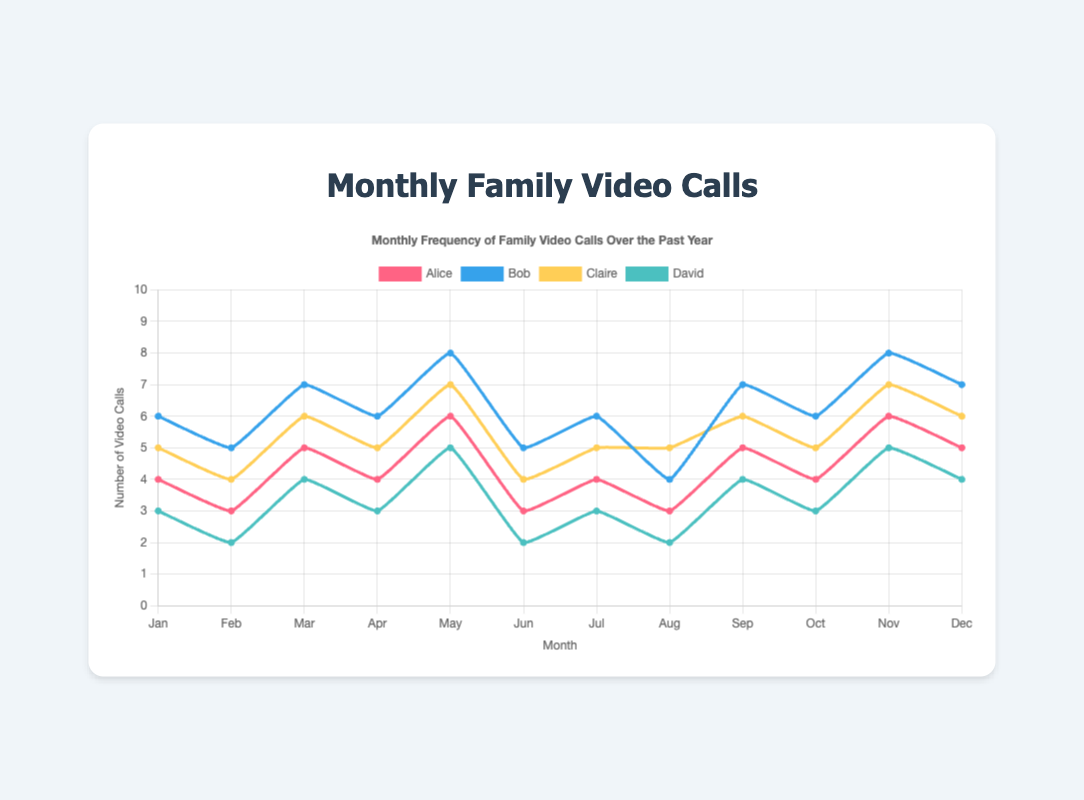What's the total number of video calls by Alice in the second half of the year? To find the total, add Alice's monthly frequency for July through December: 4 + 3 + 5 + 4 + 6 + 5 = 27
Answer: 27 Whose video call frequency was the highest in March? In March, compare the frequencies: Alice (5), Bob (7), Claire (6), David (4). Bob had the highest frequency.
Answer: Bob In which month did David have the lowest frequency of video calls? Check David's frequency across all months. David had the lowest frequency (2) in February, June, and August.
Answer: February, June, and August By how many calls did Bob's video call frequency exceed Alice's in November? In November, Bob had 8 calls and Alice had 6. The difference is 8 - 6 = 2 calls.
Answer: 2 Who had a more consistent video call frequency throughout the year, Claire or David? Calculate the range (max - min) for both: Claire's range is 7 - 4 = 3, David's range is 5 - 2 = 3. Both had the same range, comparing visually Claire seems more consistent with fewer fluctuations within her range.
Answer: Claire What's the overall trend in the frequency of Bob's video calls from January to December? Visually inspect Bob's trend: it peaks generally every two months and remains relatively high, with minor fluctuations. It seems stable with slight increases in May and November.
Answer: Stable with slight peaks If we average the number of calls for each person, who had the highest average frequency and what was it? Sum and divide each person's total across 12 months: 
- Alice: (4+3+5+4+6+3+4+3+5+4+6+5)/12 = 4.42 
- Bob: (6+5+7+6+8+5+6+4+7+6+8+7)/12 = 6.17 
- Claire: (5+4+6+5+7+4+5+5+6+5+7+6)/12 = 5.33 
- David: (3+2+4+3+5+2+3+2+4+3+5+4)/12 = 3.42. 
Bob had the highest average frequency of 6.17.
Answer: Bob, 6.17 Comparing April and October, whose frequency stayed the same? Check frequencies for April and October: Alice (4 vs. 4), Bob (6 vs. 6), Claire (5 vs. 5), David (3 vs. 3). All stayed the same.
Answer: Alice, Bob, Claire, David Which month had the highest combined number of video calls for all family members? Add up all frequencies for each month and find the maximum sum:
- January: 4+6+5+3 = 18
- February: 3+5+4+2 = 14
- March: 5+7+6+4 = 22
- April: 4+6+5+3 = 18
- May: 6+8+7+5 = 26
- June: 3+5+4+2 = 14
- July: 4+6+5+3 = 18
- August: 3+4+5+2 = 14
- September: 5+7+6+4 = 22
- October: 4+6+5+3 = 18
- November: 6+8+7+5 = 26
- December: 5+7+6+4 = 22. 
May and November both had the highest combined number of 26.
Answer: May and November What's the total number of video calls made by David over the entire year? Sum David's monthly frequency: 3 + 2 + 4 + 3 + 5 + 2 + 3 + 2 + 4 + 3 + 5 + 4 = 40
Answer: 40 